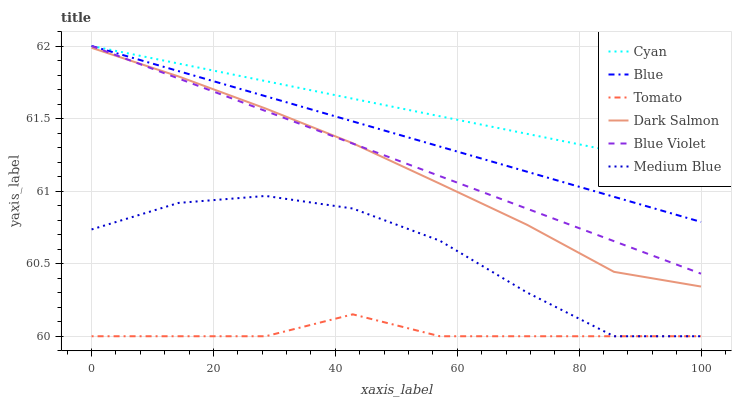Does Tomato have the minimum area under the curve?
Answer yes or no. Yes. Does Cyan have the maximum area under the curve?
Answer yes or no. Yes. Does Medium Blue have the minimum area under the curve?
Answer yes or no. No. Does Medium Blue have the maximum area under the curve?
Answer yes or no. No. Is Blue Violet the smoothest?
Answer yes or no. Yes. Is Medium Blue the roughest?
Answer yes or no. Yes. Is Tomato the smoothest?
Answer yes or no. No. Is Tomato the roughest?
Answer yes or no. No. Does Tomato have the lowest value?
Answer yes or no. Yes. Does Dark Salmon have the lowest value?
Answer yes or no. No. Does Blue Violet have the highest value?
Answer yes or no. Yes. Does Medium Blue have the highest value?
Answer yes or no. No. Is Medium Blue less than Blue Violet?
Answer yes or no. Yes. Is Blue Violet greater than Medium Blue?
Answer yes or no. Yes. Does Blue intersect Cyan?
Answer yes or no. Yes. Is Blue less than Cyan?
Answer yes or no. No. Is Blue greater than Cyan?
Answer yes or no. No. Does Medium Blue intersect Blue Violet?
Answer yes or no. No. 